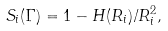<formula> <loc_0><loc_0><loc_500><loc_500>S _ { i } ( \Gamma ) = 1 - H ( R _ { i } ) / R _ { i } ^ { 2 } ,</formula> 